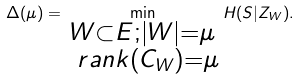Convert formula to latex. <formula><loc_0><loc_0><loc_500><loc_500>\Delta ( \mu ) = \min _ { \substack { W \subset E ; | W | = \mu \\ \ r a n k ( C _ { W } ) = \mu } } H ( S | Z _ { W } ) .</formula> 